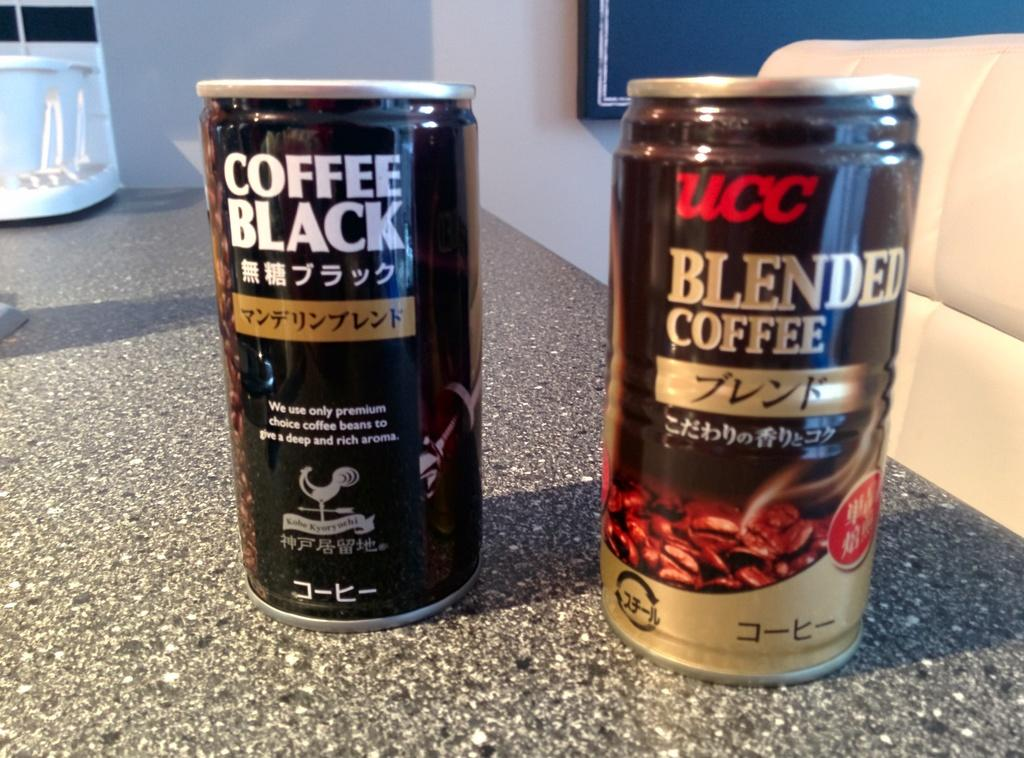<image>
Write a terse but informative summary of the picture. Two cans next to one another including one that says "Blended Coffee". 